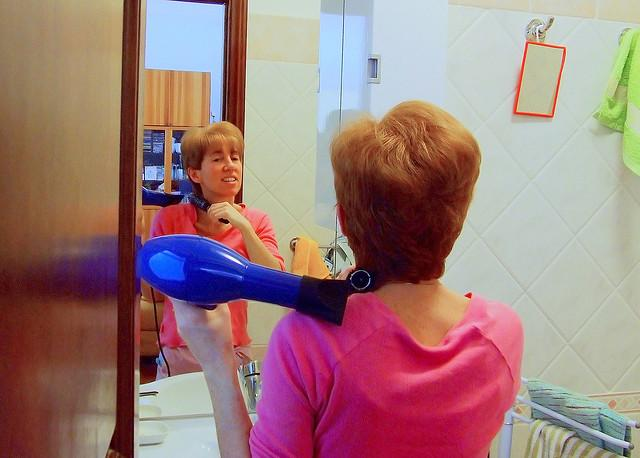What is she doing?

Choices:
A) fixing hair
B) cleaning neck
C) hiding shirt
D) heating head fixing hair 